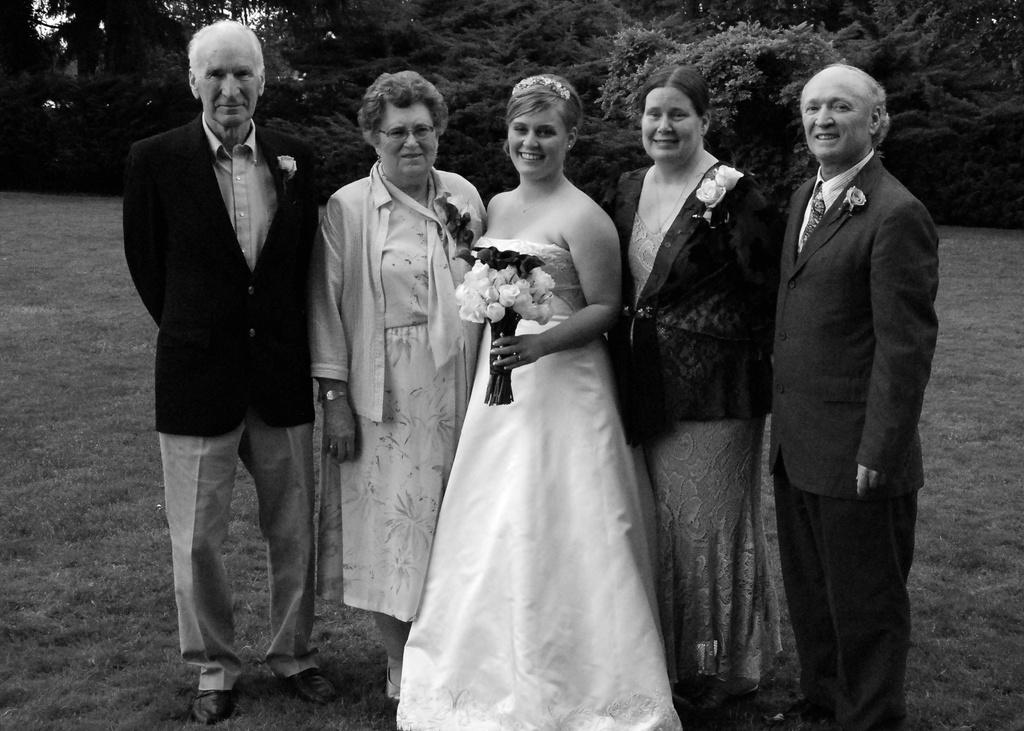What can be seen in the image? There are persons standing in the image. What is the ground like in the image? The ground is green and grassy. What is visible in the background of the image? There are trees in the background of the image. What type of loaf is being used to solve arithmetic problems in the image? There is no loaf or arithmetic problems present in the image. 